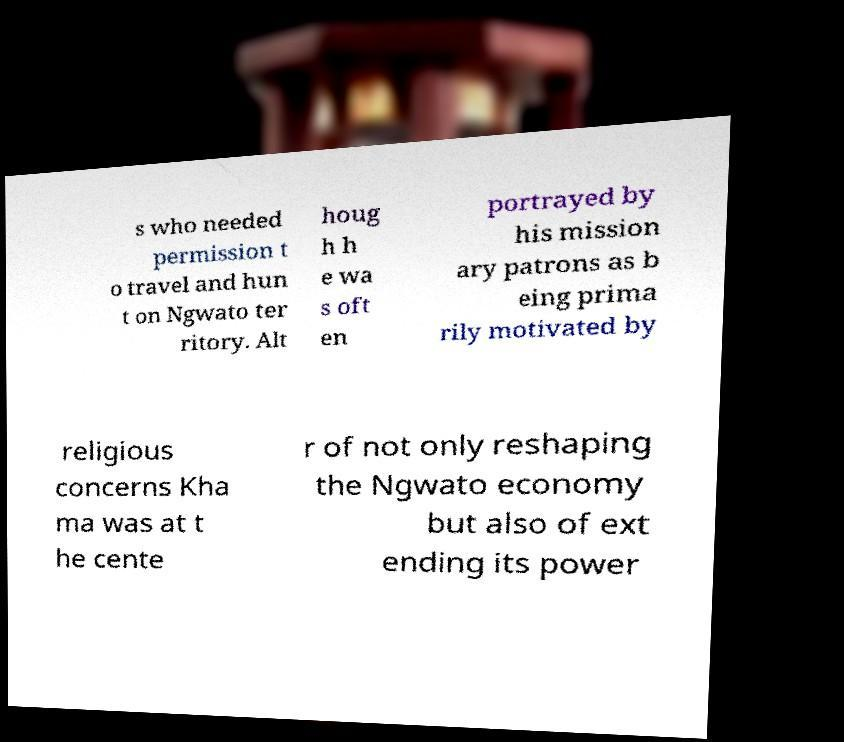Can you accurately transcribe the text from the provided image for me? s who needed permission t o travel and hun t on Ngwato ter ritory. Alt houg h h e wa s oft en portrayed by his mission ary patrons as b eing prima rily motivated by religious concerns Kha ma was at t he cente r of not only reshaping the Ngwato economy but also of ext ending its power 